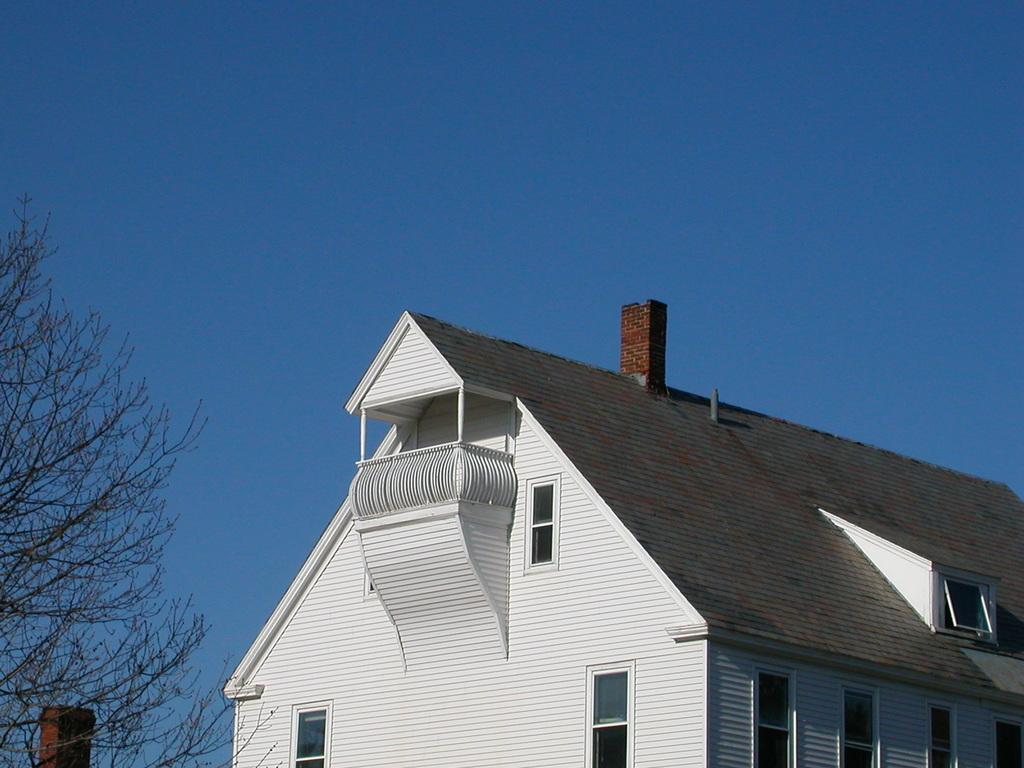What is the main subject in the center of the image? There is a building in the center of the image. What features can be observed on the building? The building has windows. What is located on the left side of the image? There is a tree and a pole on the left side of the image. What can be seen in the background of the image? The sky is visible in the background of the image. What color is the paint used to decorate the end of the trip in the image? There is no trip or paint present in the image; it features a building, a tree, a pole, and the sky. 